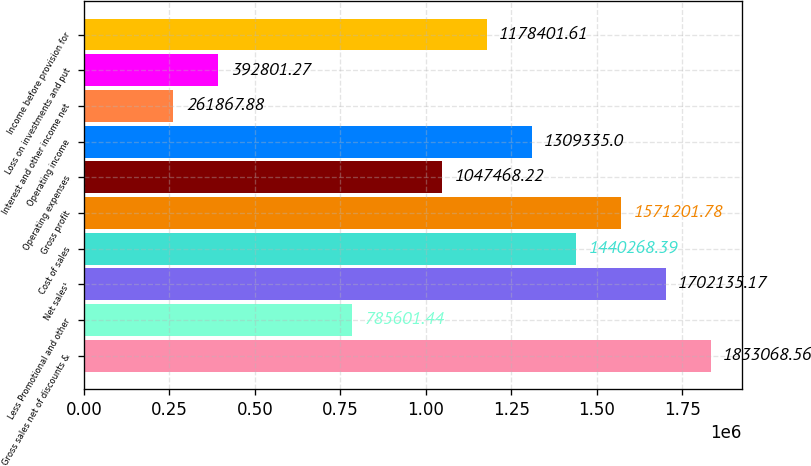Convert chart to OTSL. <chart><loc_0><loc_0><loc_500><loc_500><bar_chart><fcel>Gross sales net of discounts &<fcel>Less Promotional and other<fcel>Net sales¹<fcel>Cost of sales<fcel>Gross profit<fcel>Operating expenses<fcel>Operating income<fcel>Interest and other income net<fcel>Loss on investments and put<fcel>Income before provision for<nl><fcel>1.83307e+06<fcel>785601<fcel>1.70214e+06<fcel>1.44027e+06<fcel>1.5712e+06<fcel>1.04747e+06<fcel>1.30934e+06<fcel>261868<fcel>392801<fcel>1.1784e+06<nl></chart> 